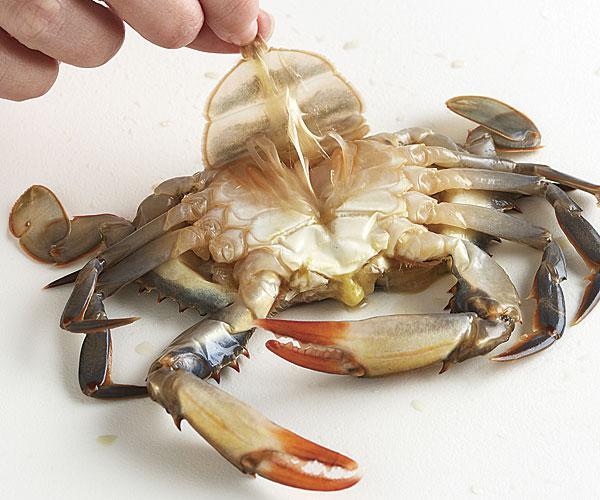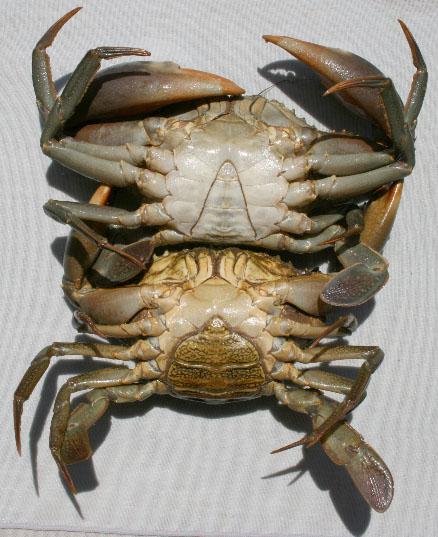The first image is the image on the left, the second image is the image on the right. For the images shown, is this caption "Both pictures show the underside of one crab and all are positioned in the same way." true? Answer yes or no. No. 